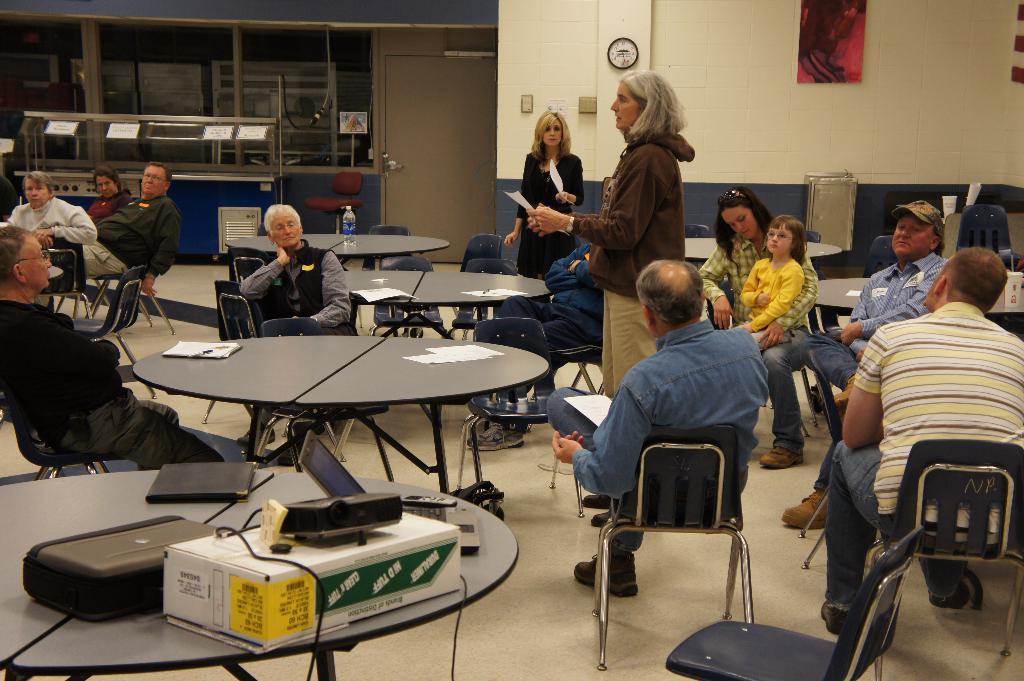Could you give a brief overview of what you see in this image? In the image there are many people sat on chairs around the tables and women in the middle holding a paper giving instructions,it seems to be of a meeting hall and our background was there is a clock and over the right side there is a photo. In middle of the room there is entrance and exit room. 